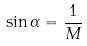Convert formula to latex. <formula><loc_0><loc_0><loc_500><loc_500>\sin \alpha = \frac { 1 } { M }</formula> 